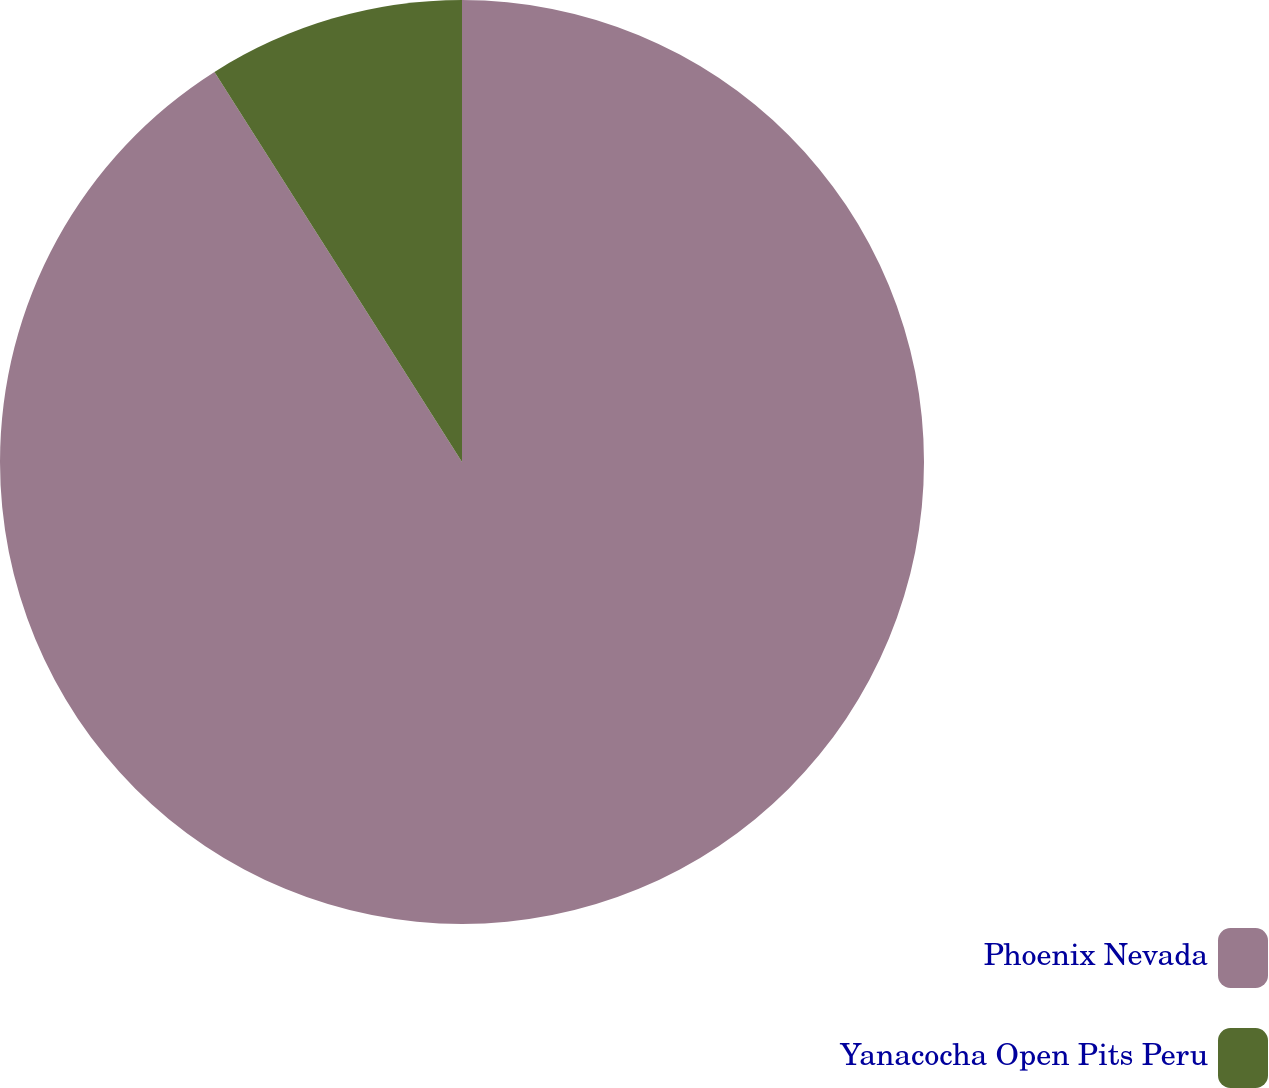<chart> <loc_0><loc_0><loc_500><loc_500><pie_chart><fcel>Phoenix Nevada<fcel>Yanacocha Open Pits Peru<nl><fcel>91.0%<fcel>9.0%<nl></chart> 